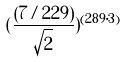Convert formula to latex. <formula><loc_0><loc_0><loc_500><loc_500>( \frac { ( 7 / 2 2 9 ) } { \sqrt { 2 } } ) ^ { ( 2 8 9 \cdot 3 ) }</formula> 